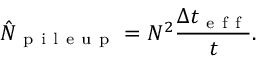Convert formula to latex. <formula><loc_0><loc_0><loc_500><loc_500>\hat { N } _ { p i l e u p } = N ^ { 2 } \frac { \Delta t _ { e f f } } { t } .</formula> 